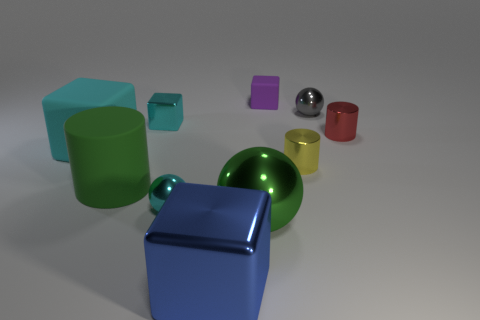Subtract all tiny cylinders. How many cylinders are left? 1 Subtract 1 spheres. How many spheres are left? 2 Subtract all spheres. How many objects are left? 7 Subtract all gray cubes. Subtract all red cylinders. How many cubes are left? 4 Subtract all big blue metallic objects. Subtract all big blue metallic cubes. How many objects are left? 8 Add 7 large shiny balls. How many large shiny balls are left? 8 Add 10 cyan rubber cylinders. How many cyan rubber cylinders exist? 10 Subtract 0 cyan cylinders. How many objects are left? 10 